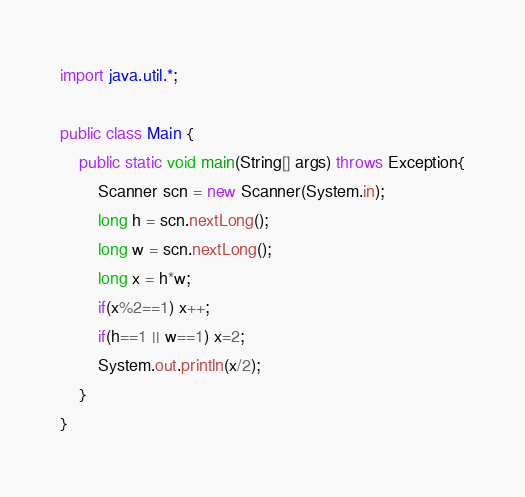Convert code to text. <code><loc_0><loc_0><loc_500><loc_500><_Java_>import java.util.*;

public class Main {
	public static void main(String[] args) throws Exception{
		Scanner scn = new Scanner(System.in);
		long h = scn.nextLong();
		long w = scn.nextLong();
      	long x = h*w;
      	if(x%2==1) x++;
      	if(h==1 || w==1) x=2;
      	System.out.println(x/2);
	}
}
</code> 